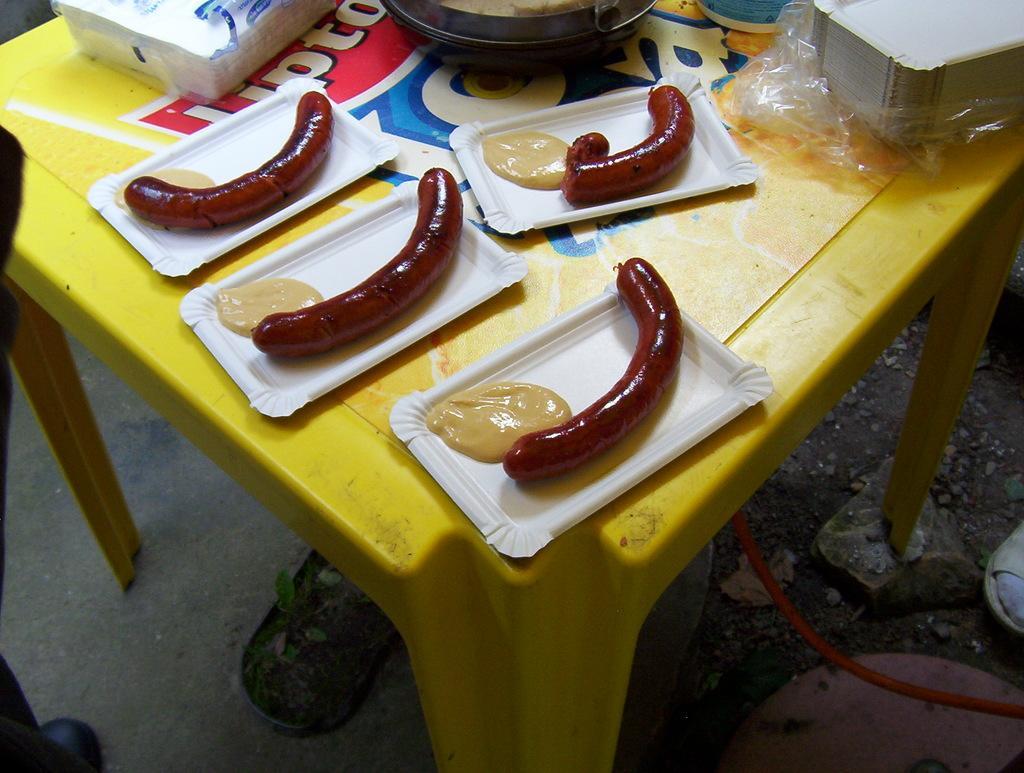How would you summarize this image in a sentence or two? In this image we can see a table, on the table, we can see some plates with some food, there are some plates, tissues, pan and some other objects, under the table we can see a potted plant. 